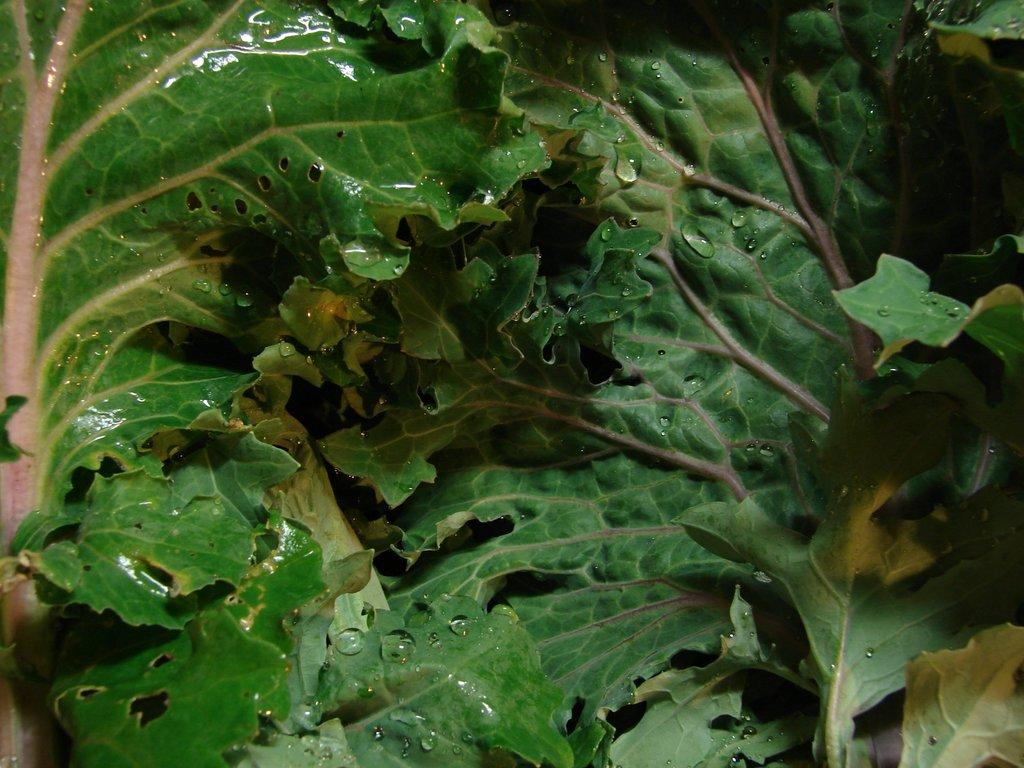What is present on the leaves in the image? There are water drops on the leaves in the image. How many tanks can be seen in the image? There are no tanks present in the image; it features water drops on leaves. What type of grade is assigned to the cows in the image? There are no cows present in the image, so no grade can be assigned. 